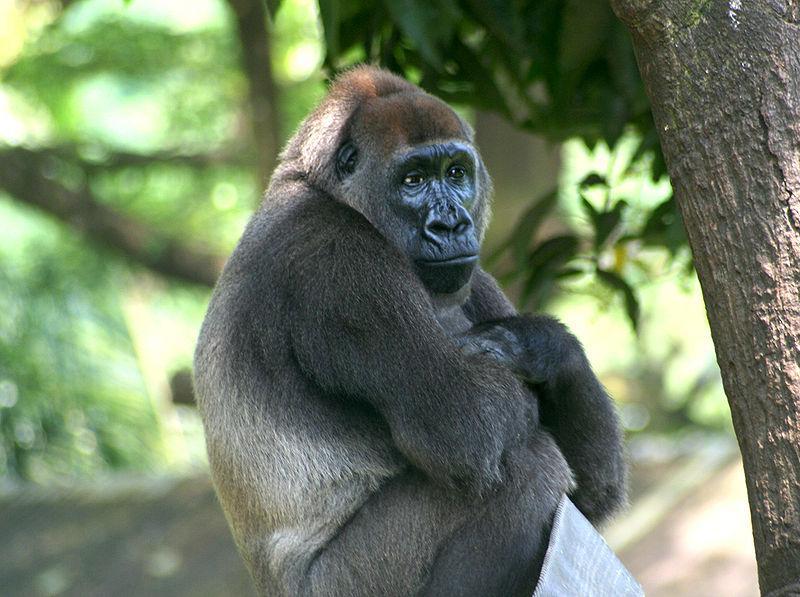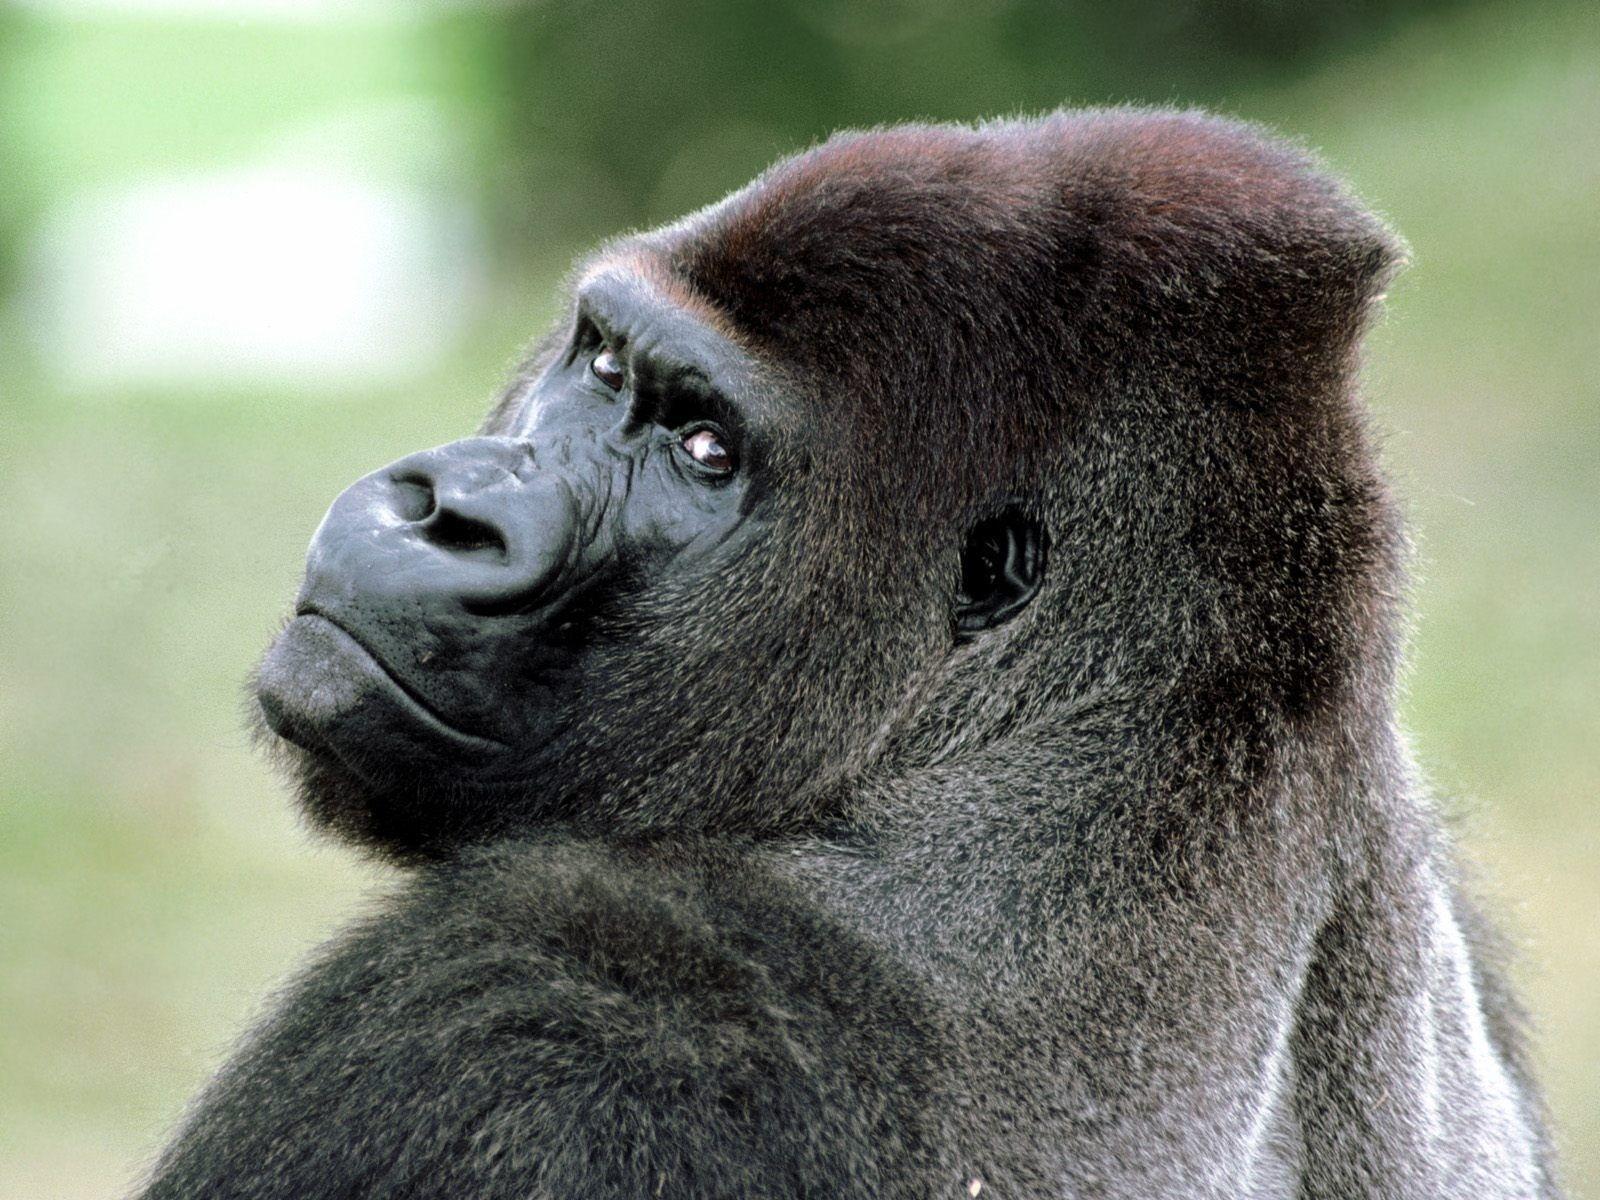The first image is the image on the left, the second image is the image on the right. For the images displayed, is the sentence "A large gorilla is on all fours in one of the images." factually correct? Answer yes or no. No. 